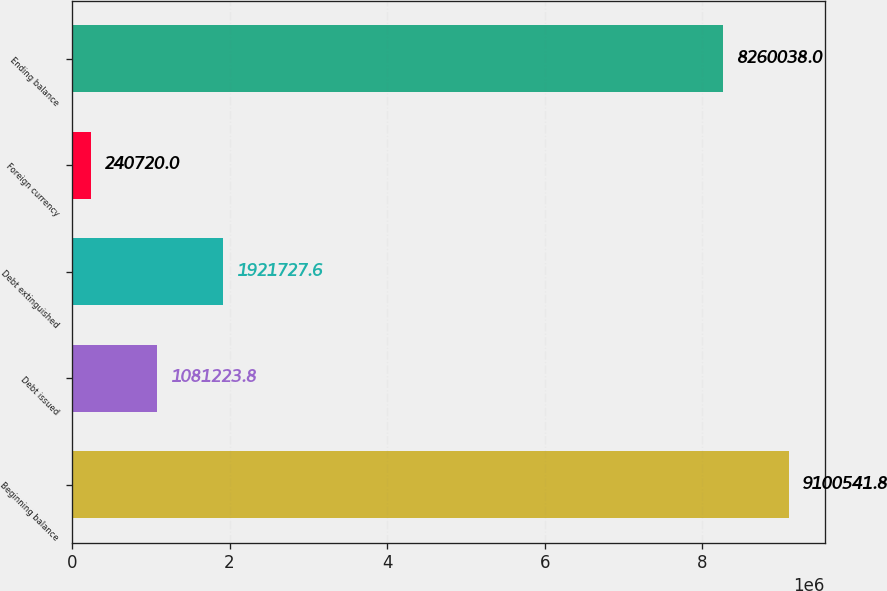Convert chart. <chart><loc_0><loc_0><loc_500><loc_500><bar_chart><fcel>Beginning balance<fcel>Debt issued<fcel>Debt extinguished<fcel>Foreign currency<fcel>Ending balance<nl><fcel>9.10054e+06<fcel>1.08122e+06<fcel>1.92173e+06<fcel>240720<fcel>8.26004e+06<nl></chart> 